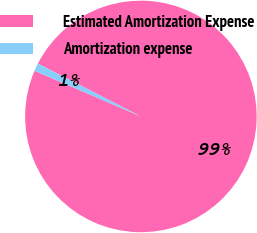Convert chart to OTSL. <chart><loc_0><loc_0><loc_500><loc_500><pie_chart><fcel>Estimated Amortization Expense<fcel>Amortization expense<nl><fcel>98.92%<fcel>1.08%<nl></chart> 